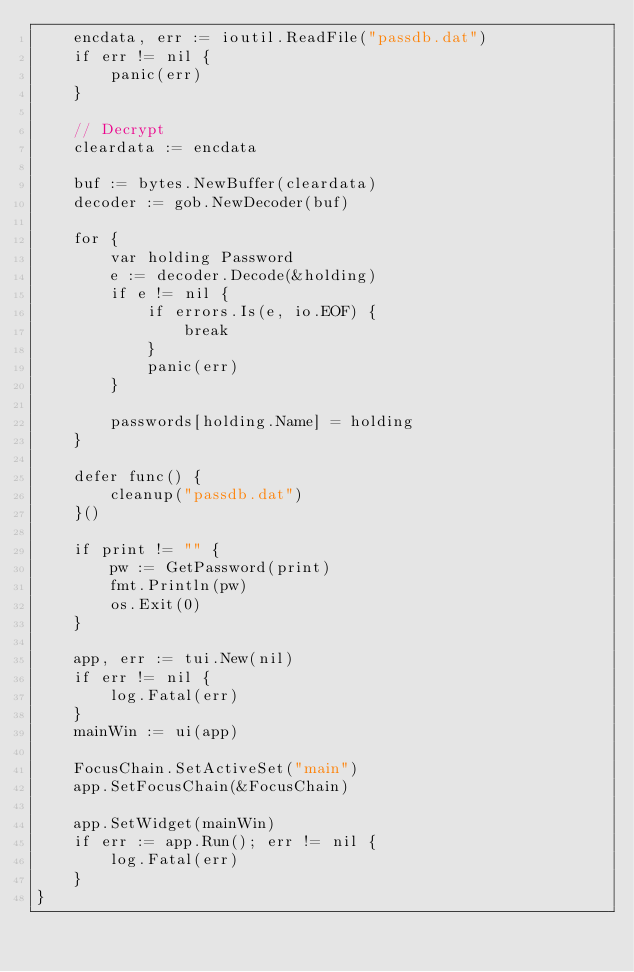<code> <loc_0><loc_0><loc_500><loc_500><_Go_>	encdata, err := ioutil.ReadFile("passdb.dat")
	if err != nil {
		panic(err)
	}

	// Decrypt
	cleardata := encdata

	buf := bytes.NewBuffer(cleardata)
	decoder := gob.NewDecoder(buf)

	for {
		var holding Password
		e := decoder.Decode(&holding)
		if e != nil {
			if errors.Is(e, io.EOF) {
				break
			}
			panic(err)
		}

		passwords[holding.Name] = holding
	}

	defer func() {
		cleanup("passdb.dat")
	}()

	if print != "" {
		pw := GetPassword(print)
		fmt.Println(pw)
		os.Exit(0)
	}

	app, err := tui.New(nil)
	if err != nil {
		log.Fatal(err)
	}
	mainWin := ui(app)

	FocusChain.SetActiveSet("main")
	app.SetFocusChain(&FocusChain)

	app.SetWidget(mainWin)
	if err := app.Run(); err != nil {
		log.Fatal(err)
	}
}
</code> 